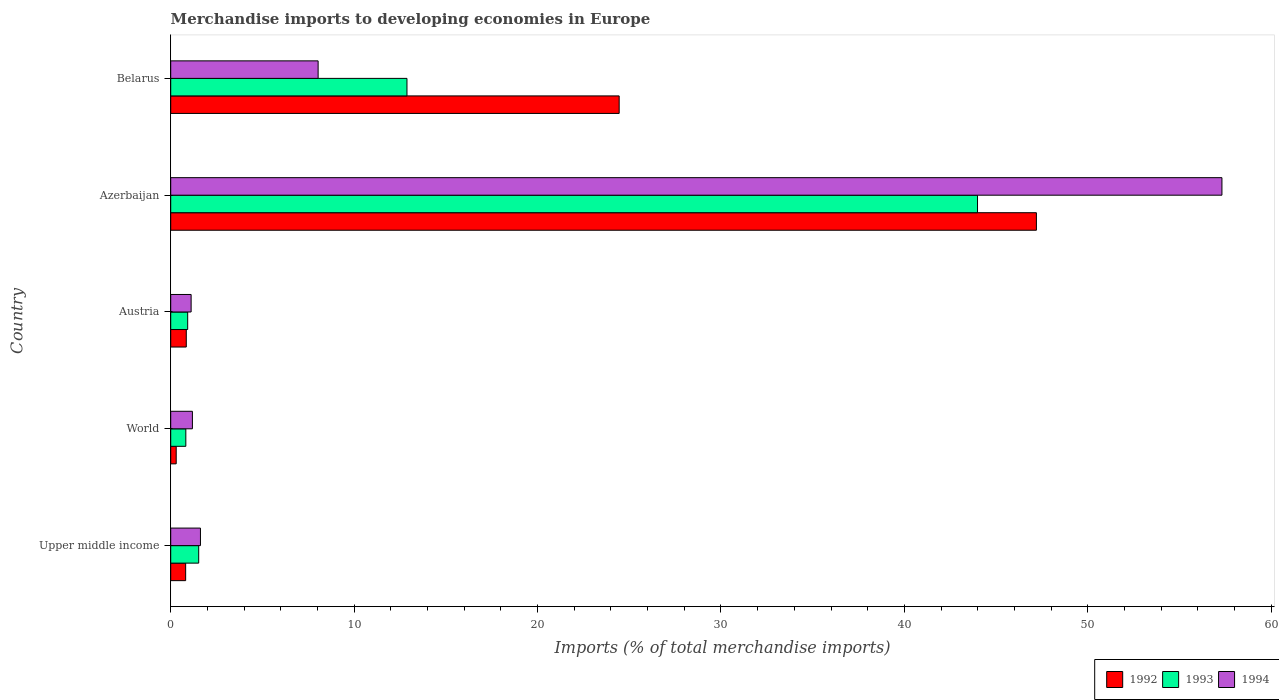How many groups of bars are there?
Give a very brief answer. 5. How many bars are there on the 3rd tick from the top?
Your response must be concise. 3. How many bars are there on the 1st tick from the bottom?
Ensure brevity in your answer.  3. What is the label of the 5th group of bars from the top?
Keep it short and to the point. Upper middle income. In how many cases, is the number of bars for a given country not equal to the number of legend labels?
Offer a terse response. 0. What is the percentage total merchandise imports in 1992 in World?
Offer a very short reply. 0.3. Across all countries, what is the maximum percentage total merchandise imports in 1993?
Your response must be concise. 43.99. Across all countries, what is the minimum percentage total merchandise imports in 1994?
Provide a succinct answer. 1.11. In which country was the percentage total merchandise imports in 1994 maximum?
Your answer should be compact. Azerbaijan. What is the total percentage total merchandise imports in 1992 in the graph?
Keep it short and to the point. 73.61. What is the difference between the percentage total merchandise imports in 1994 in Azerbaijan and that in Upper middle income?
Your answer should be very brief. 55.69. What is the difference between the percentage total merchandise imports in 1994 in Azerbaijan and the percentage total merchandise imports in 1992 in Austria?
Provide a short and direct response. 56.46. What is the average percentage total merchandise imports in 1992 per country?
Offer a terse response. 14.72. What is the difference between the percentage total merchandise imports in 1993 and percentage total merchandise imports in 1992 in Belarus?
Offer a very short reply. -11.57. What is the ratio of the percentage total merchandise imports in 1993 in Belarus to that in World?
Give a very brief answer. 15.63. Is the percentage total merchandise imports in 1993 in Upper middle income less than that in World?
Keep it short and to the point. No. Is the difference between the percentage total merchandise imports in 1993 in Upper middle income and World greater than the difference between the percentage total merchandise imports in 1992 in Upper middle income and World?
Give a very brief answer. Yes. What is the difference between the highest and the second highest percentage total merchandise imports in 1992?
Ensure brevity in your answer.  22.75. What is the difference between the highest and the lowest percentage total merchandise imports in 1992?
Provide a succinct answer. 46.9. In how many countries, is the percentage total merchandise imports in 1992 greater than the average percentage total merchandise imports in 1992 taken over all countries?
Keep it short and to the point. 2. Is the sum of the percentage total merchandise imports in 1994 in Belarus and World greater than the maximum percentage total merchandise imports in 1993 across all countries?
Keep it short and to the point. No. What does the 1st bar from the top in Belarus represents?
Offer a terse response. 1994. How many bars are there?
Your answer should be compact. 15. How many countries are there in the graph?
Your response must be concise. 5. What is the difference between two consecutive major ticks on the X-axis?
Provide a short and direct response. 10. Does the graph contain any zero values?
Provide a succinct answer. No. Does the graph contain grids?
Give a very brief answer. No. Where does the legend appear in the graph?
Give a very brief answer. Bottom right. How many legend labels are there?
Keep it short and to the point. 3. What is the title of the graph?
Keep it short and to the point. Merchandise imports to developing economies in Europe. Does "1998" appear as one of the legend labels in the graph?
Provide a short and direct response. No. What is the label or title of the X-axis?
Give a very brief answer. Imports (% of total merchandise imports). What is the Imports (% of total merchandise imports) of 1992 in Upper middle income?
Your answer should be compact. 0.81. What is the Imports (% of total merchandise imports) of 1993 in Upper middle income?
Your response must be concise. 1.53. What is the Imports (% of total merchandise imports) in 1994 in Upper middle income?
Offer a very short reply. 1.62. What is the Imports (% of total merchandise imports) in 1992 in World?
Make the answer very short. 0.3. What is the Imports (% of total merchandise imports) in 1993 in World?
Your answer should be very brief. 0.82. What is the Imports (% of total merchandise imports) in 1994 in World?
Offer a very short reply. 1.18. What is the Imports (% of total merchandise imports) of 1992 in Austria?
Your answer should be compact. 0.85. What is the Imports (% of total merchandise imports) of 1993 in Austria?
Your response must be concise. 0.93. What is the Imports (% of total merchandise imports) of 1994 in Austria?
Provide a succinct answer. 1.11. What is the Imports (% of total merchandise imports) of 1992 in Azerbaijan?
Keep it short and to the point. 47.2. What is the Imports (% of total merchandise imports) of 1993 in Azerbaijan?
Offer a terse response. 43.99. What is the Imports (% of total merchandise imports) in 1994 in Azerbaijan?
Offer a terse response. 57.31. What is the Imports (% of total merchandise imports) of 1992 in Belarus?
Offer a terse response. 24.45. What is the Imports (% of total merchandise imports) in 1993 in Belarus?
Provide a succinct answer. 12.88. What is the Imports (% of total merchandise imports) of 1994 in Belarus?
Your response must be concise. 8.04. Across all countries, what is the maximum Imports (% of total merchandise imports) in 1992?
Offer a terse response. 47.2. Across all countries, what is the maximum Imports (% of total merchandise imports) in 1993?
Your response must be concise. 43.99. Across all countries, what is the maximum Imports (% of total merchandise imports) of 1994?
Make the answer very short. 57.31. Across all countries, what is the minimum Imports (% of total merchandise imports) of 1992?
Your response must be concise. 0.3. Across all countries, what is the minimum Imports (% of total merchandise imports) of 1993?
Offer a very short reply. 0.82. Across all countries, what is the minimum Imports (% of total merchandise imports) of 1994?
Keep it short and to the point. 1.11. What is the total Imports (% of total merchandise imports) of 1992 in the graph?
Your answer should be compact. 73.61. What is the total Imports (% of total merchandise imports) in 1993 in the graph?
Offer a terse response. 60.14. What is the total Imports (% of total merchandise imports) in 1994 in the graph?
Your answer should be very brief. 69.27. What is the difference between the Imports (% of total merchandise imports) of 1992 in Upper middle income and that in World?
Offer a terse response. 0.52. What is the difference between the Imports (% of total merchandise imports) of 1993 in Upper middle income and that in World?
Provide a short and direct response. 0.7. What is the difference between the Imports (% of total merchandise imports) of 1994 in Upper middle income and that in World?
Your answer should be compact. 0.44. What is the difference between the Imports (% of total merchandise imports) in 1992 in Upper middle income and that in Austria?
Your answer should be very brief. -0.03. What is the difference between the Imports (% of total merchandise imports) of 1993 in Upper middle income and that in Austria?
Make the answer very short. 0.6. What is the difference between the Imports (% of total merchandise imports) of 1994 in Upper middle income and that in Austria?
Provide a succinct answer. 0.51. What is the difference between the Imports (% of total merchandise imports) of 1992 in Upper middle income and that in Azerbaijan?
Offer a terse response. -46.38. What is the difference between the Imports (% of total merchandise imports) of 1993 in Upper middle income and that in Azerbaijan?
Give a very brief answer. -42.46. What is the difference between the Imports (% of total merchandise imports) of 1994 in Upper middle income and that in Azerbaijan?
Ensure brevity in your answer.  -55.69. What is the difference between the Imports (% of total merchandise imports) in 1992 in Upper middle income and that in Belarus?
Keep it short and to the point. -23.64. What is the difference between the Imports (% of total merchandise imports) of 1993 in Upper middle income and that in Belarus?
Ensure brevity in your answer.  -11.35. What is the difference between the Imports (% of total merchandise imports) in 1994 in Upper middle income and that in Belarus?
Offer a terse response. -6.42. What is the difference between the Imports (% of total merchandise imports) of 1992 in World and that in Austria?
Your answer should be compact. -0.55. What is the difference between the Imports (% of total merchandise imports) of 1993 in World and that in Austria?
Make the answer very short. -0.1. What is the difference between the Imports (% of total merchandise imports) in 1994 in World and that in Austria?
Give a very brief answer. 0.07. What is the difference between the Imports (% of total merchandise imports) in 1992 in World and that in Azerbaijan?
Keep it short and to the point. -46.9. What is the difference between the Imports (% of total merchandise imports) of 1993 in World and that in Azerbaijan?
Provide a succinct answer. -43.16. What is the difference between the Imports (% of total merchandise imports) in 1994 in World and that in Azerbaijan?
Provide a short and direct response. -56.13. What is the difference between the Imports (% of total merchandise imports) of 1992 in World and that in Belarus?
Your answer should be very brief. -24.15. What is the difference between the Imports (% of total merchandise imports) in 1993 in World and that in Belarus?
Make the answer very short. -12.06. What is the difference between the Imports (% of total merchandise imports) in 1994 in World and that in Belarus?
Your answer should be compact. -6.85. What is the difference between the Imports (% of total merchandise imports) in 1992 in Austria and that in Azerbaijan?
Ensure brevity in your answer.  -46.35. What is the difference between the Imports (% of total merchandise imports) in 1993 in Austria and that in Azerbaijan?
Ensure brevity in your answer.  -43.06. What is the difference between the Imports (% of total merchandise imports) of 1994 in Austria and that in Azerbaijan?
Offer a terse response. -56.2. What is the difference between the Imports (% of total merchandise imports) of 1992 in Austria and that in Belarus?
Your answer should be compact. -23.6. What is the difference between the Imports (% of total merchandise imports) in 1993 in Austria and that in Belarus?
Your response must be concise. -11.95. What is the difference between the Imports (% of total merchandise imports) in 1994 in Austria and that in Belarus?
Your answer should be compact. -6.92. What is the difference between the Imports (% of total merchandise imports) in 1992 in Azerbaijan and that in Belarus?
Provide a succinct answer. 22.75. What is the difference between the Imports (% of total merchandise imports) of 1993 in Azerbaijan and that in Belarus?
Your response must be concise. 31.11. What is the difference between the Imports (% of total merchandise imports) in 1994 in Azerbaijan and that in Belarus?
Provide a short and direct response. 49.28. What is the difference between the Imports (% of total merchandise imports) in 1992 in Upper middle income and the Imports (% of total merchandise imports) in 1993 in World?
Offer a terse response. -0.01. What is the difference between the Imports (% of total merchandise imports) of 1992 in Upper middle income and the Imports (% of total merchandise imports) of 1994 in World?
Offer a terse response. -0.37. What is the difference between the Imports (% of total merchandise imports) in 1993 in Upper middle income and the Imports (% of total merchandise imports) in 1994 in World?
Give a very brief answer. 0.34. What is the difference between the Imports (% of total merchandise imports) of 1992 in Upper middle income and the Imports (% of total merchandise imports) of 1993 in Austria?
Provide a short and direct response. -0.11. What is the difference between the Imports (% of total merchandise imports) in 1992 in Upper middle income and the Imports (% of total merchandise imports) in 1994 in Austria?
Give a very brief answer. -0.3. What is the difference between the Imports (% of total merchandise imports) of 1993 in Upper middle income and the Imports (% of total merchandise imports) of 1994 in Austria?
Your response must be concise. 0.41. What is the difference between the Imports (% of total merchandise imports) in 1992 in Upper middle income and the Imports (% of total merchandise imports) in 1993 in Azerbaijan?
Offer a terse response. -43.17. What is the difference between the Imports (% of total merchandise imports) of 1992 in Upper middle income and the Imports (% of total merchandise imports) of 1994 in Azerbaijan?
Make the answer very short. -56.5. What is the difference between the Imports (% of total merchandise imports) in 1993 in Upper middle income and the Imports (% of total merchandise imports) in 1994 in Azerbaijan?
Make the answer very short. -55.79. What is the difference between the Imports (% of total merchandise imports) of 1992 in Upper middle income and the Imports (% of total merchandise imports) of 1993 in Belarus?
Offer a terse response. -12.07. What is the difference between the Imports (% of total merchandise imports) of 1992 in Upper middle income and the Imports (% of total merchandise imports) of 1994 in Belarus?
Your answer should be very brief. -7.22. What is the difference between the Imports (% of total merchandise imports) in 1993 in Upper middle income and the Imports (% of total merchandise imports) in 1994 in Belarus?
Ensure brevity in your answer.  -6.51. What is the difference between the Imports (% of total merchandise imports) of 1992 in World and the Imports (% of total merchandise imports) of 1993 in Austria?
Your response must be concise. -0.63. What is the difference between the Imports (% of total merchandise imports) of 1992 in World and the Imports (% of total merchandise imports) of 1994 in Austria?
Your answer should be very brief. -0.81. What is the difference between the Imports (% of total merchandise imports) in 1993 in World and the Imports (% of total merchandise imports) in 1994 in Austria?
Offer a terse response. -0.29. What is the difference between the Imports (% of total merchandise imports) of 1992 in World and the Imports (% of total merchandise imports) of 1993 in Azerbaijan?
Offer a terse response. -43.69. What is the difference between the Imports (% of total merchandise imports) of 1992 in World and the Imports (% of total merchandise imports) of 1994 in Azerbaijan?
Provide a short and direct response. -57.01. What is the difference between the Imports (% of total merchandise imports) of 1993 in World and the Imports (% of total merchandise imports) of 1994 in Azerbaijan?
Your response must be concise. -56.49. What is the difference between the Imports (% of total merchandise imports) of 1992 in World and the Imports (% of total merchandise imports) of 1993 in Belarus?
Your answer should be compact. -12.58. What is the difference between the Imports (% of total merchandise imports) of 1992 in World and the Imports (% of total merchandise imports) of 1994 in Belarus?
Offer a very short reply. -7.74. What is the difference between the Imports (% of total merchandise imports) in 1993 in World and the Imports (% of total merchandise imports) in 1994 in Belarus?
Your response must be concise. -7.21. What is the difference between the Imports (% of total merchandise imports) of 1992 in Austria and the Imports (% of total merchandise imports) of 1993 in Azerbaijan?
Offer a very short reply. -43.14. What is the difference between the Imports (% of total merchandise imports) of 1992 in Austria and the Imports (% of total merchandise imports) of 1994 in Azerbaijan?
Keep it short and to the point. -56.46. What is the difference between the Imports (% of total merchandise imports) in 1993 in Austria and the Imports (% of total merchandise imports) in 1994 in Azerbaijan?
Offer a terse response. -56.39. What is the difference between the Imports (% of total merchandise imports) of 1992 in Austria and the Imports (% of total merchandise imports) of 1993 in Belarus?
Provide a succinct answer. -12.03. What is the difference between the Imports (% of total merchandise imports) of 1992 in Austria and the Imports (% of total merchandise imports) of 1994 in Belarus?
Offer a very short reply. -7.19. What is the difference between the Imports (% of total merchandise imports) of 1993 in Austria and the Imports (% of total merchandise imports) of 1994 in Belarus?
Ensure brevity in your answer.  -7.11. What is the difference between the Imports (% of total merchandise imports) in 1992 in Azerbaijan and the Imports (% of total merchandise imports) in 1993 in Belarus?
Offer a terse response. 34.32. What is the difference between the Imports (% of total merchandise imports) of 1992 in Azerbaijan and the Imports (% of total merchandise imports) of 1994 in Belarus?
Provide a succinct answer. 39.16. What is the difference between the Imports (% of total merchandise imports) in 1993 in Azerbaijan and the Imports (% of total merchandise imports) in 1994 in Belarus?
Ensure brevity in your answer.  35.95. What is the average Imports (% of total merchandise imports) of 1992 per country?
Your answer should be compact. 14.72. What is the average Imports (% of total merchandise imports) in 1993 per country?
Keep it short and to the point. 12.03. What is the average Imports (% of total merchandise imports) of 1994 per country?
Offer a very short reply. 13.85. What is the difference between the Imports (% of total merchandise imports) in 1992 and Imports (% of total merchandise imports) in 1993 in Upper middle income?
Offer a very short reply. -0.71. What is the difference between the Imports (% of total merchandise imports) of 1992 and Imports (% of total merchandise imports) of 1994 in Upper middle income?
Provide a succinct answer. -0.81. What is the difference between the Imports (% of total merchandise imports) in 1993 and Imports (% of total merchandise imports) in 1994 in Upper middle income?
Provide a succinct answer. -0.1. What is the difference between the Imports (% of total merchandise imports) in 1992 and Imports (% of total merchandise imports) in 1993 in World?
Offer a terse response. -0.52. What is the difference between the Imports (% of total merchandise imports) of 1992 and Imports (% of total merchandise imports) of 1994 in World?
Provide a succinct answer. -0.88. What is the difference between the Imports (% of total merchandise imports) in 1993 and Imports (% of total merchandise imports) in 1994 in World?
Ensure brevity in your answer.  -0.36. What is the difference between the Imports (% of total merchandise imports) of 1992 and Imports (% of total merchandise imports) of 1993 in Austria?
Make the answer very short. -0.08. What is the difference between the Imports (% of total merchandise imports) of 1992 and Imports (% of total merchandise imports) of 1994 in Austria?
Provide a succinct answer. -0.26. What is the difference between the Imports (% of total merchandise imports) of 1993 and Imports (% of total merchandise imports) of 1994 in Austria?
Give a very brief answer. -0.19. What is the difference between the Imports (% of total merchandise imports) of 1992 and Imports (% of total merchandise imports) of 1993 in Azerbaijan?
Your response must be concise. 3.21. What is the difference between the Imports (% of total merchandise imports) in 1992 and Imports (% of total merchandise imports) in 1994 in Azerbaijan?
Your answer should be very brief. -10.11. What is the difference between the Imports (% of total merchandise imports) in 1993 and Imports (% of total merchandise imports) in 1994 in Azerbaijan?
Your answer should be very brief. -13.33. What is the difference between the Imports (% of total merchandise imports) in 1992 and Imports (% of total merchandise imports) in 1993 in Belarus?
Ensure brevity in your answer.  11.57. What is the difference between the Imports (% of total merchandise imports) in 1992 and Imports (% of total merchandise imports) in 1994 in Belarus?
Give a very brief answer. 16.41. What is the difference between the Imports (% of total merchandise imports) in 1993 and Imports (% of total merchandise imports) in 1994 in Belarus?
Ensure brevity in your answer.  4.84. What is the ratio of the Imports (% of total merchandise imports) of 1992 in Upper middle income to that in World?
Offer a very short reply. 2.72. What is the ratio of the Imports (% of total merchandise imports) of 1993 in Upper middle income to that in World?
Keep it short and to the point. 1.85. What is the ratio of the Imports (% of total merchandise imports) in 1994 in Upper middle income to that in World?
Provide a succinct answer. 1.37. What is the ratio of the Imports (% of total merchandise imports) in 1992 in Upper middle income to that in Austria?
Keep it short and to the point. 0.96. What is the ratio of the Imports (% of total merchandise imports) of 1993 in Upper middle income to that in Austria?
Ensure brevity in your answer.  1.65. What is the ratio of the Imports (% of total merchandise imports) in 1994 in Upper middle income to that in Austria?
Offer a terse response. 1.46. What is the ratio of the Imports (% of total merchandise imports) in 1992 in Upper middle income to that in Azerbaijan?
Give a very brief answer. 0.02. What is the ratio of the Imports (% of total merchandise imports) in 1993 in Upper middle income to that in Azerbaijan?
Offer a very short reply. 0.03. What is the ratio of the Imports (% of total merchandise imports) of 1994 in Upper middle income to that in Azerbaijan?
Offer a terse response. 0.03. What is the ratio of the Imports (% of total merchandise imports) in 1993 in Upper middle income to that in Belarus?
Keep it short and to the point. 0.12. What is the ratio of the Imports (% of total merchandise imports) in 1994 in Upper middle income to that in Belarus?
Keep it short and to the point. 0.2. What is the ratio of the Imports (% of total merchandise imports) in 1992 in World to that in Austria?
Your response must be concise. 0.35. What is the ratio of the Imports (% of total merchandise imports) in 1993 in World to that in Austria?
Give a very brief answer. 0.89. What is the ratio of the Imports (% of total merchandise imports) in 1994 in World to that in Austria?
Your answer should be compact. 1.06. What is the ratio of the Imports (% of total merchandise imports) of 1992 in World to that in Azerbaijan?
Provide a short and direct response. 0.01. What is the ratio of the Imports (% of total merchandise imports) in 1993 in World to that in Azerbaijan?
Keep it short and to the point. 0.02. What is the ratio of the Imports (% of total merchandise imports) in 1994 in World to that in Azerbaijan?
Keep it short and to the point. 0.02. What is the ratio of the Imports (% of total merchandise imports) in 1992 in World to that in Belarus?
Keep it short and to the point. 0.01. What is the ratio of the Imports (% of total merchandise imports) of 1993 in World to that in Belarus?
Your answer should be very brief. 0.06. What is the ratio of the Imports (% of total merchandise imports) of 1994 in World to that in Belarus?
Provide a short and direct response. 0.15. What is the ratio of the Imports (% of total merchandise imports) in 1992 in Austria to that in Azerbaijan?
Make the answer very short. 0.02. What is the ratio of the Imports (% of total merchandise imports) of 1993 in Austria to that in Azerbaijan?
Your answer should be very brief. 0.02. What is the ratio of the Imports (% of total merchandise imports) of 1994 in Austria to that in Azerbaijan?
Provide a succinct answer. 0.02. What is the ratio of the Imports (% of total merchandise imports) in 1992 in Austria to that in Belarus?
Ensure brevity in your answer.  0.03. What is the ratio of the Imports (% of total merchandise imports) of 1993 in Austria to that in Belarus?
Your response must be concise. 0.07. What is the ratio of the Imports (% of total merchandise imports) in 1994 in Austria to that in Belarus?
Make the answer very short. 0.14. What is the ratio of the Imports (% of total merchandise imports) of 1992 in Azerbaijan to that in Belarus?
Give a very brief answer. 1.93. What is the ratio of the Imports (% of total merchandise imports) of 1993 in Azerbaijan to that in Belarus?
Ensure brevity in your answer.  3.42. What is the ratio of the Imports (% of total merchandise imports) of 1994 in Azerbaijan to that in Belarus?
Ensure brevity in your answer.  7.13. What is the difference between the highest and the second highest Imports (% of total merchandise imports) in 1992?
Your answer should be very brief. 22.75. What is the difference between the highest and the second highest Imports (% of total merchandise imports) of 1993?
Your answer should be compact. 31.11. What is the difference between the highest and the second highest Imports (% of total merchandise imports) in 1994?
Provide a succinct answer. 49.28. What is the difference between the highest and the lowest Imports (% of total merchandise imports) in 1992?
Your answer should be compact. 46.9. What is the difference between the highest and the lowest Imports (% of total merchandise imports) of 1993?
Your answer should be compact. 43.16. What is the difference between the highest and the lowest Imports (% of total merchandise imports) in 1994?
Your answer should be very brief. 56.2. 